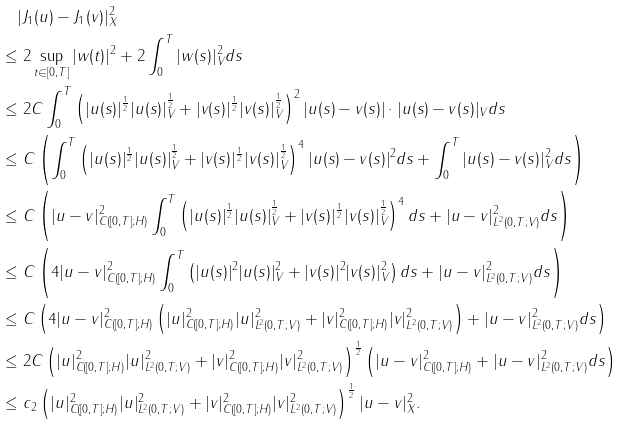Convert formula to latex. <formula><loc_0><loc_0><loc_500><loc_500>& \quad | J _ { 1 } ( u ) - J _ { 1 } ( v ) | ^ { 2 } _ { X } \\ & \leq 2 \sup _ { t \in [ 0 , T ] } | w ( t ) | ^ { 2 } + 2 \int _ { 0 } ^ { T } | w ( s ) | _ { V } ^ { 2 } d s \\ & \leq 2 C \int _ { 0 } ^ { T } \left ( | u ( s ) | ^ { \frac { 1 } { 2 } } | u ( s ) | ^ { \frac { 1 } { 2 } } _ { V } + | v ( s ) | ^ { \frac { 1 } { 2 } } | v ( s ) | ^ { \frac { 1 } { 2 } } _ { V } \right ) ^ { 2 } | u ( s ) - v ( s ) | \cdot | u ( s ) - v ( s ) | _ { V } d s \\ & \leq C \left ( \int _ { 0 } ^ { T } \left ( | u ( s ) | ^ { \frac { 1 } { 2 } } | u ( s ) | ^ { \frac { 1 } { 2 } } _ { V } + | v ( s ) | ^ { \frac { 1 } { 2 } } | v ( s ) | ^ { \frac { 1 } { 2 } } _ { V } \right ) ^ { 4 } | u ( s ) - v ( s ) | ^ { 2 } d s + \int _ { 0 } ^ { T } | u ( s ) - v ( s ) | _ { V } ^ { 2 } d s \right ) \\ & \leq C \left ( | u - v | _ { C ( [ 0 , T ] ; H ) } ^ { 2 } \int _ { 0 } ^ { T } \left ( | u ( s ) | ^ { \frac { 1 } { 2 } } | u ( s ) | ^ { \frac { 1 } { 2 } } _ { V } + | v ( s ) | ^ { \frac { 1 } { 2 } } | v ( s ) | ^ { \frac { 1 } { 2 } } _ { V } \right ) ^ { 4 } d s + | u - v | _ { L ^ { 2 } ( 0 , T ; V ) } ^ { 2 } d s \right ) \\ & \leq C \left ( 4 | u - v | _ { C ( [ 0 , T ] ; H ) } ^ { 2 } \int _ { 0 } ^ { T } \left ( | u ( s ) | ^ { 2 } | u ( s ) | ^ { 2 } _ { V } + | v ( s ) | ^ { 2 } | v ( s ) | ^ { 2 } _ { V } \right ) d s + | u - v | _ { L ^ { 2 } ( 0 , T ; V ) } ^ { 2 } d s \right ) \\ & \leq C \left ( 4 | u - v | _ { C ( [ 0 , T ] ; H ) } ^ { 2 } \left ( | u | ^ { 2 } _ { C ( [ 0 , T ] ; H ) } | u | ^ { 2 } _ { L ^ { 2 } ( 0 , T ; V ) } + | v | ^ { 2 } _ { C ( [ 0 , T ] ; H ) } | v | ^ { 2 } _ { L ^ { 2 } ( 0 , T ; V ) } \right ) + | u - v | _ { L ^ { 2 } ( 0 , T ; V ) } ^ { 2 } d s \right ) \\ & \leq 2 C \left ( | u | ^ { 2 } _ { C ( [ 0 , T ] ; H ) } | u | ^ { 2 } _ { L ^ { 2 } ( 0 , T ; V ) } + | v | ^ { 2 } _ { C ( [ 0 , T ] ; H ) } | v | ^ { 2 } _ { L ^ { 2 } ( 0 , T ; V ) } \right ) ^ { \frac { 1 } { 2 } } \left ( | u - v | _ { C ( [ 0 , T ] ; H ) } ^ { 2 } + | u - v | _ { L ^ { 2 } ( 0 , T ; V ) } ^ { 2 } d s \right ) \\ & \leq c _ { 2 } \left ( | u | ^ { 2 } _ { C ( [ 0 , T ] ; H ) } | u | ^ { 2 } _ { L ^ { 2 } ( 0 , T ; V ) } + | v | ^ { 2 } _ { C ( [ 0 , T ] ; H ) } | v | ^ { 2 } _ { L ^ { 2 } ( 0 , T ; V ) } \right ) ^ { \frac { 1 } { 2 } } | u - v | _ { X } ^ { 2 } .</formula> 